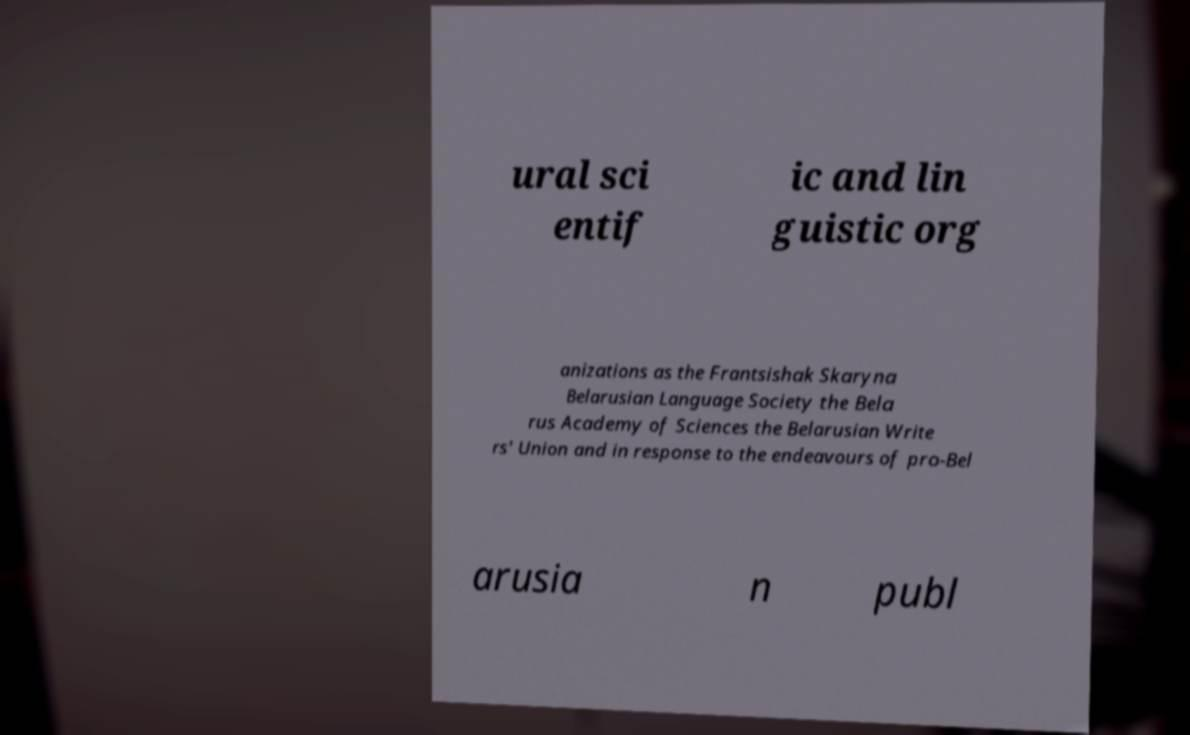What messages or text are displayed in this image? I need them in a readable, typed format. ural sci entif ic and lin guistic org anizations as the Frantsishak Skaryna Belarusian Language Society the Bela rus Academy of Sciences the Belarusian Write rs' Union and in response to the endeavours of pro-Bel arusia n publ 